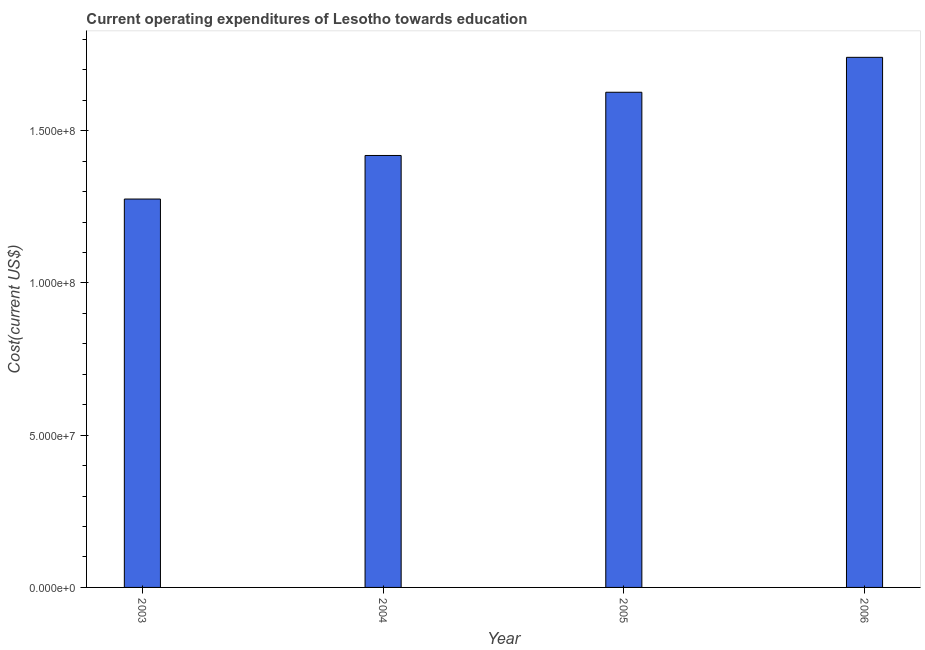Does the graph contain any zero values?
Ensure brevity in your answer.  No. Does the graph contain grids?
Offer a very short reply. No. What is the title of the graph?
Offer a terse response. Current operating expenditures of Lesotho towards education. What is the label or title of the X-axis?
Make the answer very short. Year. What is the label or title of the Y-axis?
Your answer should be very brief. Cost(current US$). What is the education expenditure in 2006?
Offer a terse response. 1.74e+08. Across all years, what is the maximum education expenditure?
Your response must be concise. 1.74e+08. Across all years, what is the minimum education expenditure?
Keep it short and to the point. 1.28e+08. In which year was the education expenditure maximum?
Provide a succinct answer. 2006. In which year was the education expenditure minimum?
Ensure brevity in your answer.  2003. What is the sum of the education expenditure?
Offer a terse response. 6.06e+08. What is the difference between the education expenditure in 2004 and 2005?
Provide a succinct answer. -2.08e+07. What is the average education expenditure per year?
Keep it short and to the point. 1.52e+08. What is the median education expenditure?
Your answer should be very brief. 1.52e+08. In how many years, is the education expenditure greater than 160000000 US$?
Keep it short and to the point. 2. What is the ratio of the education expenditure in 2005 to that in 2006?
Make the answer very short. 0.93. What is the difference between the highest and the second highest education expenditure?
Your response must be concise. 1.15e+07. What is the difference between the highest and the lowest education expenditure?
Keep it short and to the point. 4.65e+07. In how many years, is the education expenditure greater than the average education expenditure taken over all years?
Provide a succinct answer. 2. Are all the bars in the graph horizontal?
Make the answer very short. No. What is the difference between two consecutive major ticks on the Y-axis?
Provide a short and direct response. 5.00e+07. What is the Cost(current US$) in 2003?
Provide a succinct answer. 1.28e+08. What is the Cost(current US$) of 2004?
Provide a succinct answer. 1.42e+08. What is the Cost(current US$) of 2005?
Your answer should be compact. 1.63e+08. What is the Cost(current US$) in 2006?
Your answer should be compact. 1.74e+08. What is the difference between the Cost(current US$) in 2003 and 2004?
Make the answer very short. -1.43e+07. What is the difference between the Cost(current US$) in 2003 and 2005?
Give a very brief answer. -3.51e+07. What is the difference between the Cost(current US$) in 2003 and 2006?
Keep it short and to the point. -4.65e+07. What is the difference between the Cost(current US$) in 2004 and 2005?
Your answer should be compact. -2.08e+07. What is the difference between the Cost(current US$) in 2004 and 2006?
Keep it short and to the point. -3.22e+07. What is the difference between the Cost(current US$) in 2005 and 2006?
Your answer should be very brief. -1.15e+07. What is the ratio of the Cost(current US$) in 2003 to that in 2004?
Offer a terse response. 0.9. What is the ratio of the Cost(current US$) in 2003 to that in 2005?
Provide a short and direct response. 0.78. What is the ratio of the Cost(current US$) in 2003 to that in 2006?
Provide a succinct answer. 0.73. What is the ratio of the Cost(current US$) in 2004 to that in 2005?
Provide a succinct answer. 0.87. What is the ratio of the Cost(current US$) in 2004 to that in 2006?
Your response must be concise. 0.81. What is the ratio of the Cost(current US$) in 2005 to that in 2006?
Give a very brief answer. 0.93. 